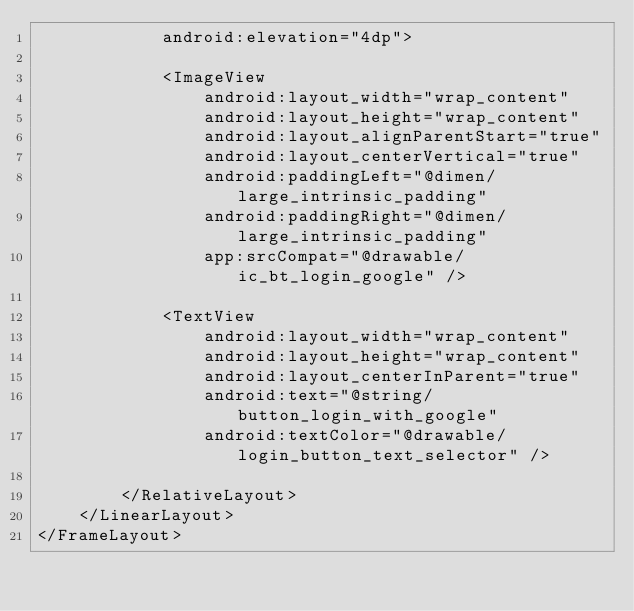<code> <loc_0><loc_0><loc_500><loc_500><_XML_>            android:elevation="4dp">

            <ImageView
                android:layout_width="wrap_content"
                android:layout_height="wrap_content"
                android:layout_alignParentStart="true"
                android:layout_centerVertical="true"
                android:paddingLeft="@dimen/large_intrinsic_padding"
                android:paddingRight="@dimen/large_intrinsic_padding"
                app:srcCompat="@drawable/ic_bt_login_google" />

            <TextView
                android:layout_width="wrap_content"
                android:layout_height="wrap_content"
                android:layout_centerInParent="true"
                android:text="@string/button_login_with_google"
                android:textColor="@drawable/login_button_text_selector" />

        </RelativeLayout>
    </LinearLayout>
</FrameLayout>

</code> 